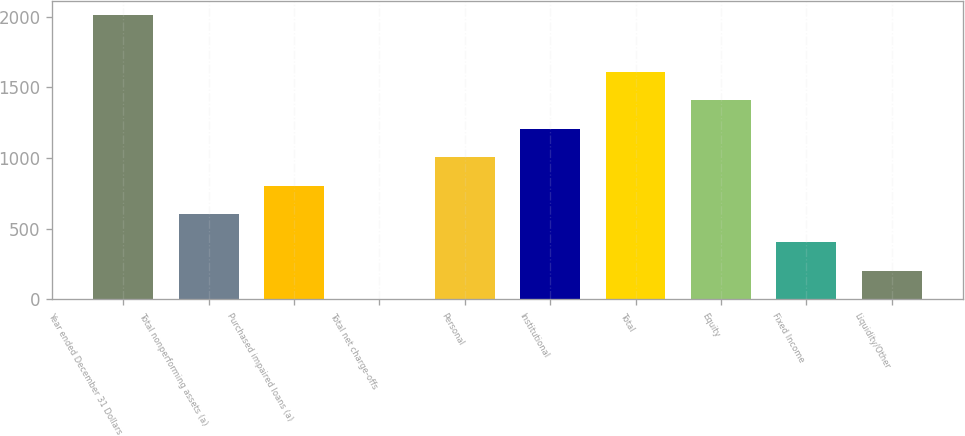<chart> <loc_0><loc_0><loc_500><loc_500><bar_chart><fcel>Year ended December 31 Dollars<fcel>Total nonperforming assets (a)<fcel>Purchased impaired loans (a)<fcel>Total net charge-offs<fcel>Personal<fcel>Institutional<fcel>Total<fcel>Equity<fcel>Fixed Income<fcel>Liquidity/Other<nl><fcel>2013<fcel>604.6<fcel>805.8<fcel>1<fcel>1007<fcel>1208.2<fcel>1610.6<fcel>1409.4<fcel>403.4<fcel>202.2<nl></chart> 